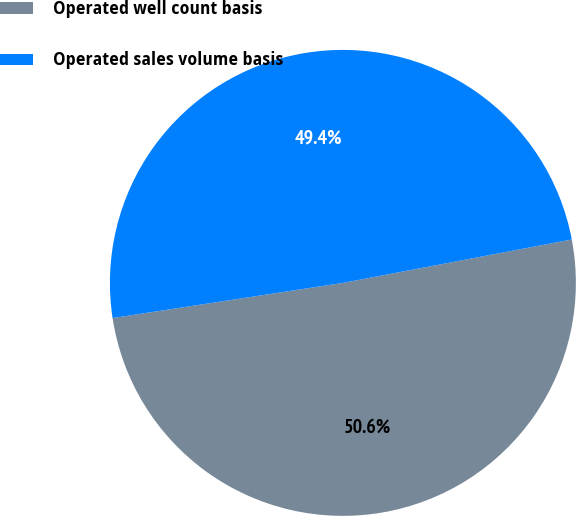Convert chart. <chart><loc_0><loc_0><loc_500><loc_500><pie_chart><fcel>Operated well count basis<fcel>Operated sales volume basis<nl><fcel>50.57%<fcel>49.43%<nl></chart> 